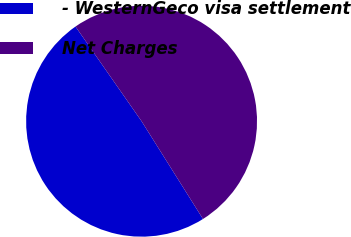Convert chart. <chart><loc_0><loc_0><loc_500><loc_500><pie_chart><fcel>- WesternGeco visa settlement<fcel>Net Charges<nl><fcel>49.23%<fcel>50.77%<nl></chart> 